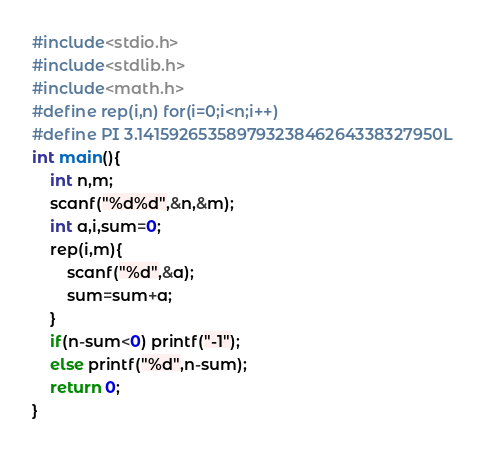<code> <loc_0><loc_0><loc_500><loc_500><_C_>#include<stdio.h>
#include<stdlib.h>
#include<math.h>
#define rep(i,n) for(i=0;i<n;i++)
#define PI 3.14159265358979323846264338327950L
int main(){
    int n,m;
    scanf("%d%d",&n,&m);
    int a,i,sum=0;
    rep(i,m){
        scanf("%d",&a);
        sum=sum+a;
    }
    if(n-sum<0) printf("-1");
    else printf("%d",n-sum);
    return 0;
}</code> 